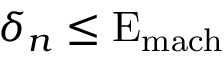Convert formula to latex. <formula><loc_0><loc_0><loc_500><loc_500>\delta _ { n } \leq E _ { m a c h }</formula> 